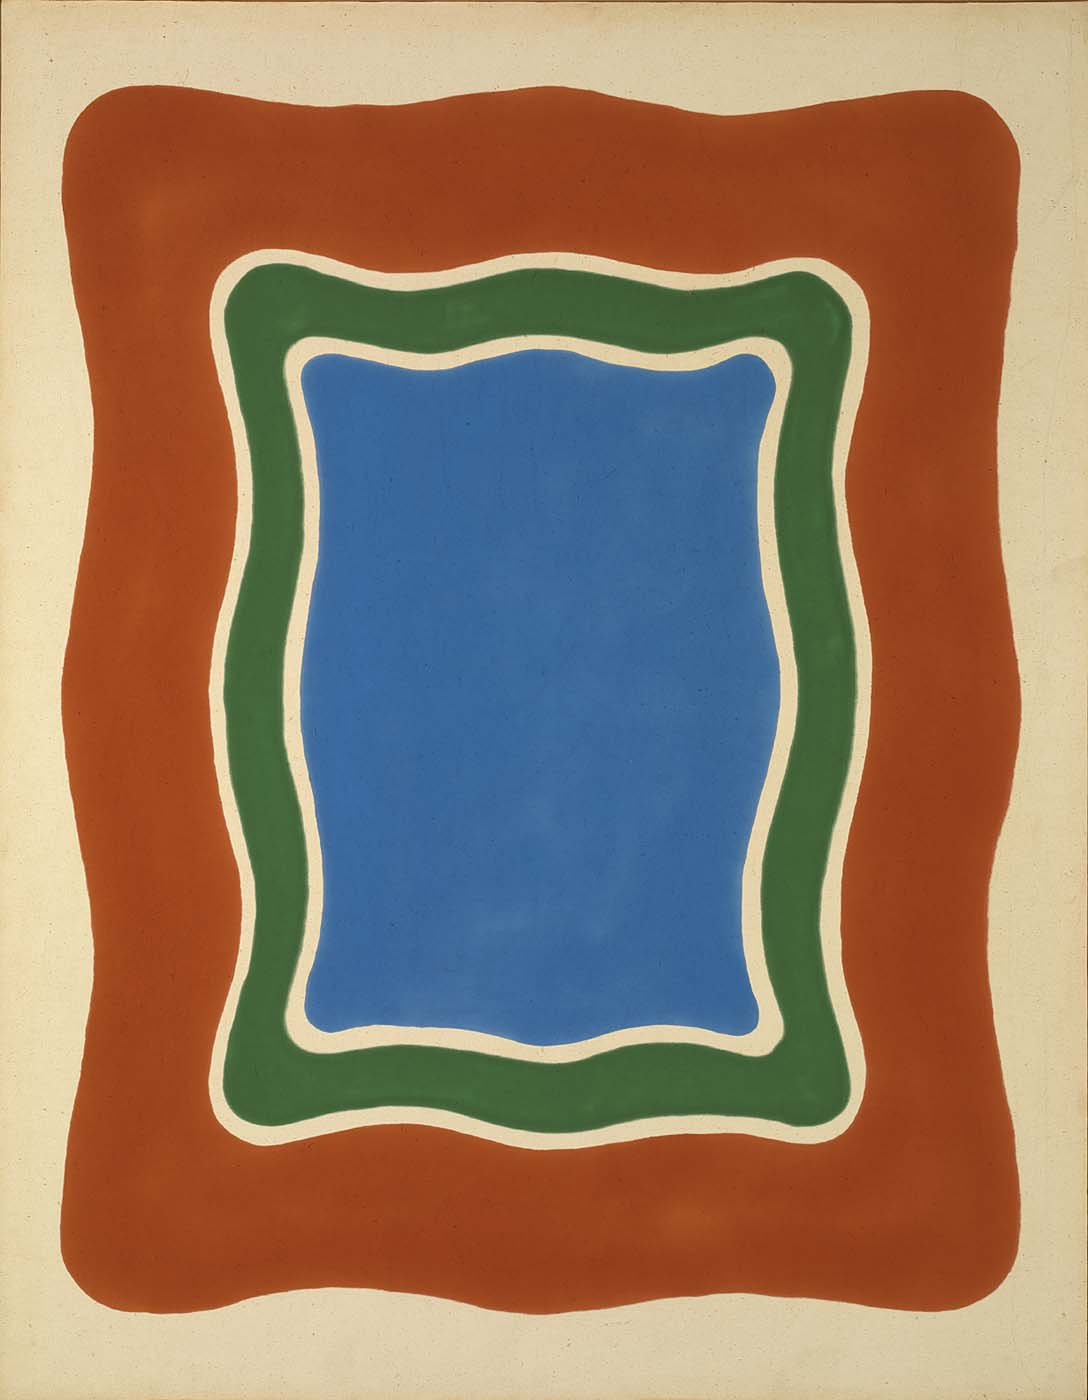How does the surrounding red background influence the perception of the central shapes? The red background intensifies the visual impact of the central blue and green shapes. Red is a color often associated with energy and urgency, which creates a striking contrast against the tranquility of the blue. This juxtaposition may be seen as a representation of dynamic energy surrounding a calm center, possibly reflecting on the human condition surrounded by the pressures and chaos of life. 